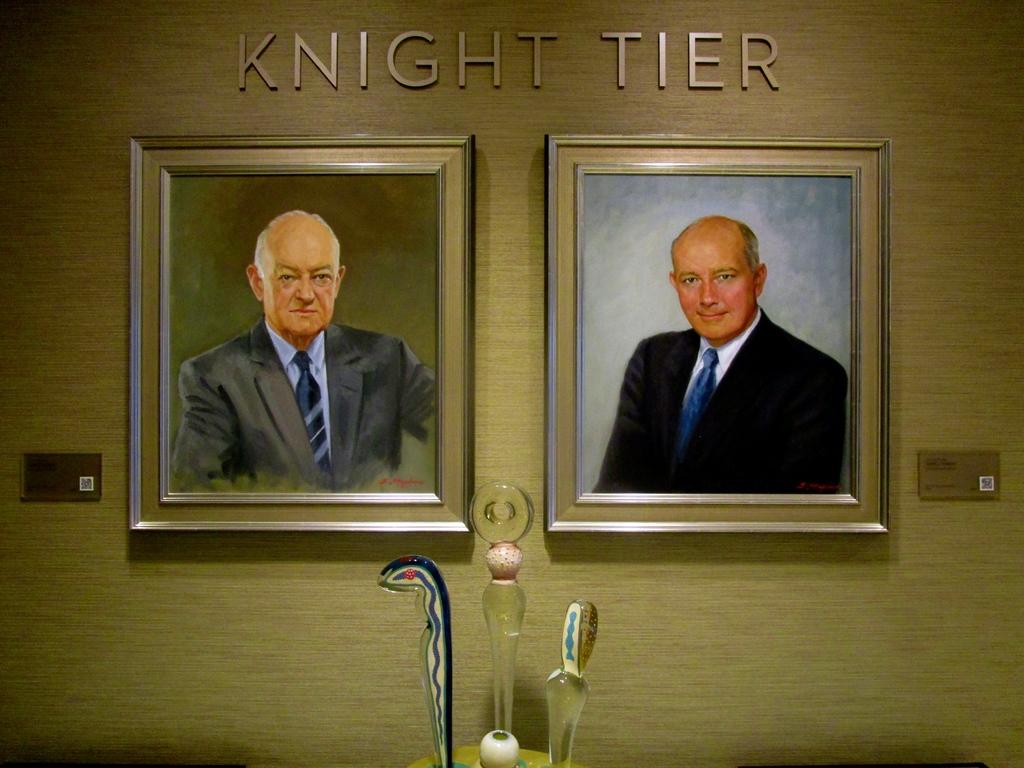What kind of tier?
Your answer should be compact. Knight. What are the two names?
Provide a succinct answer. Knight tier. 